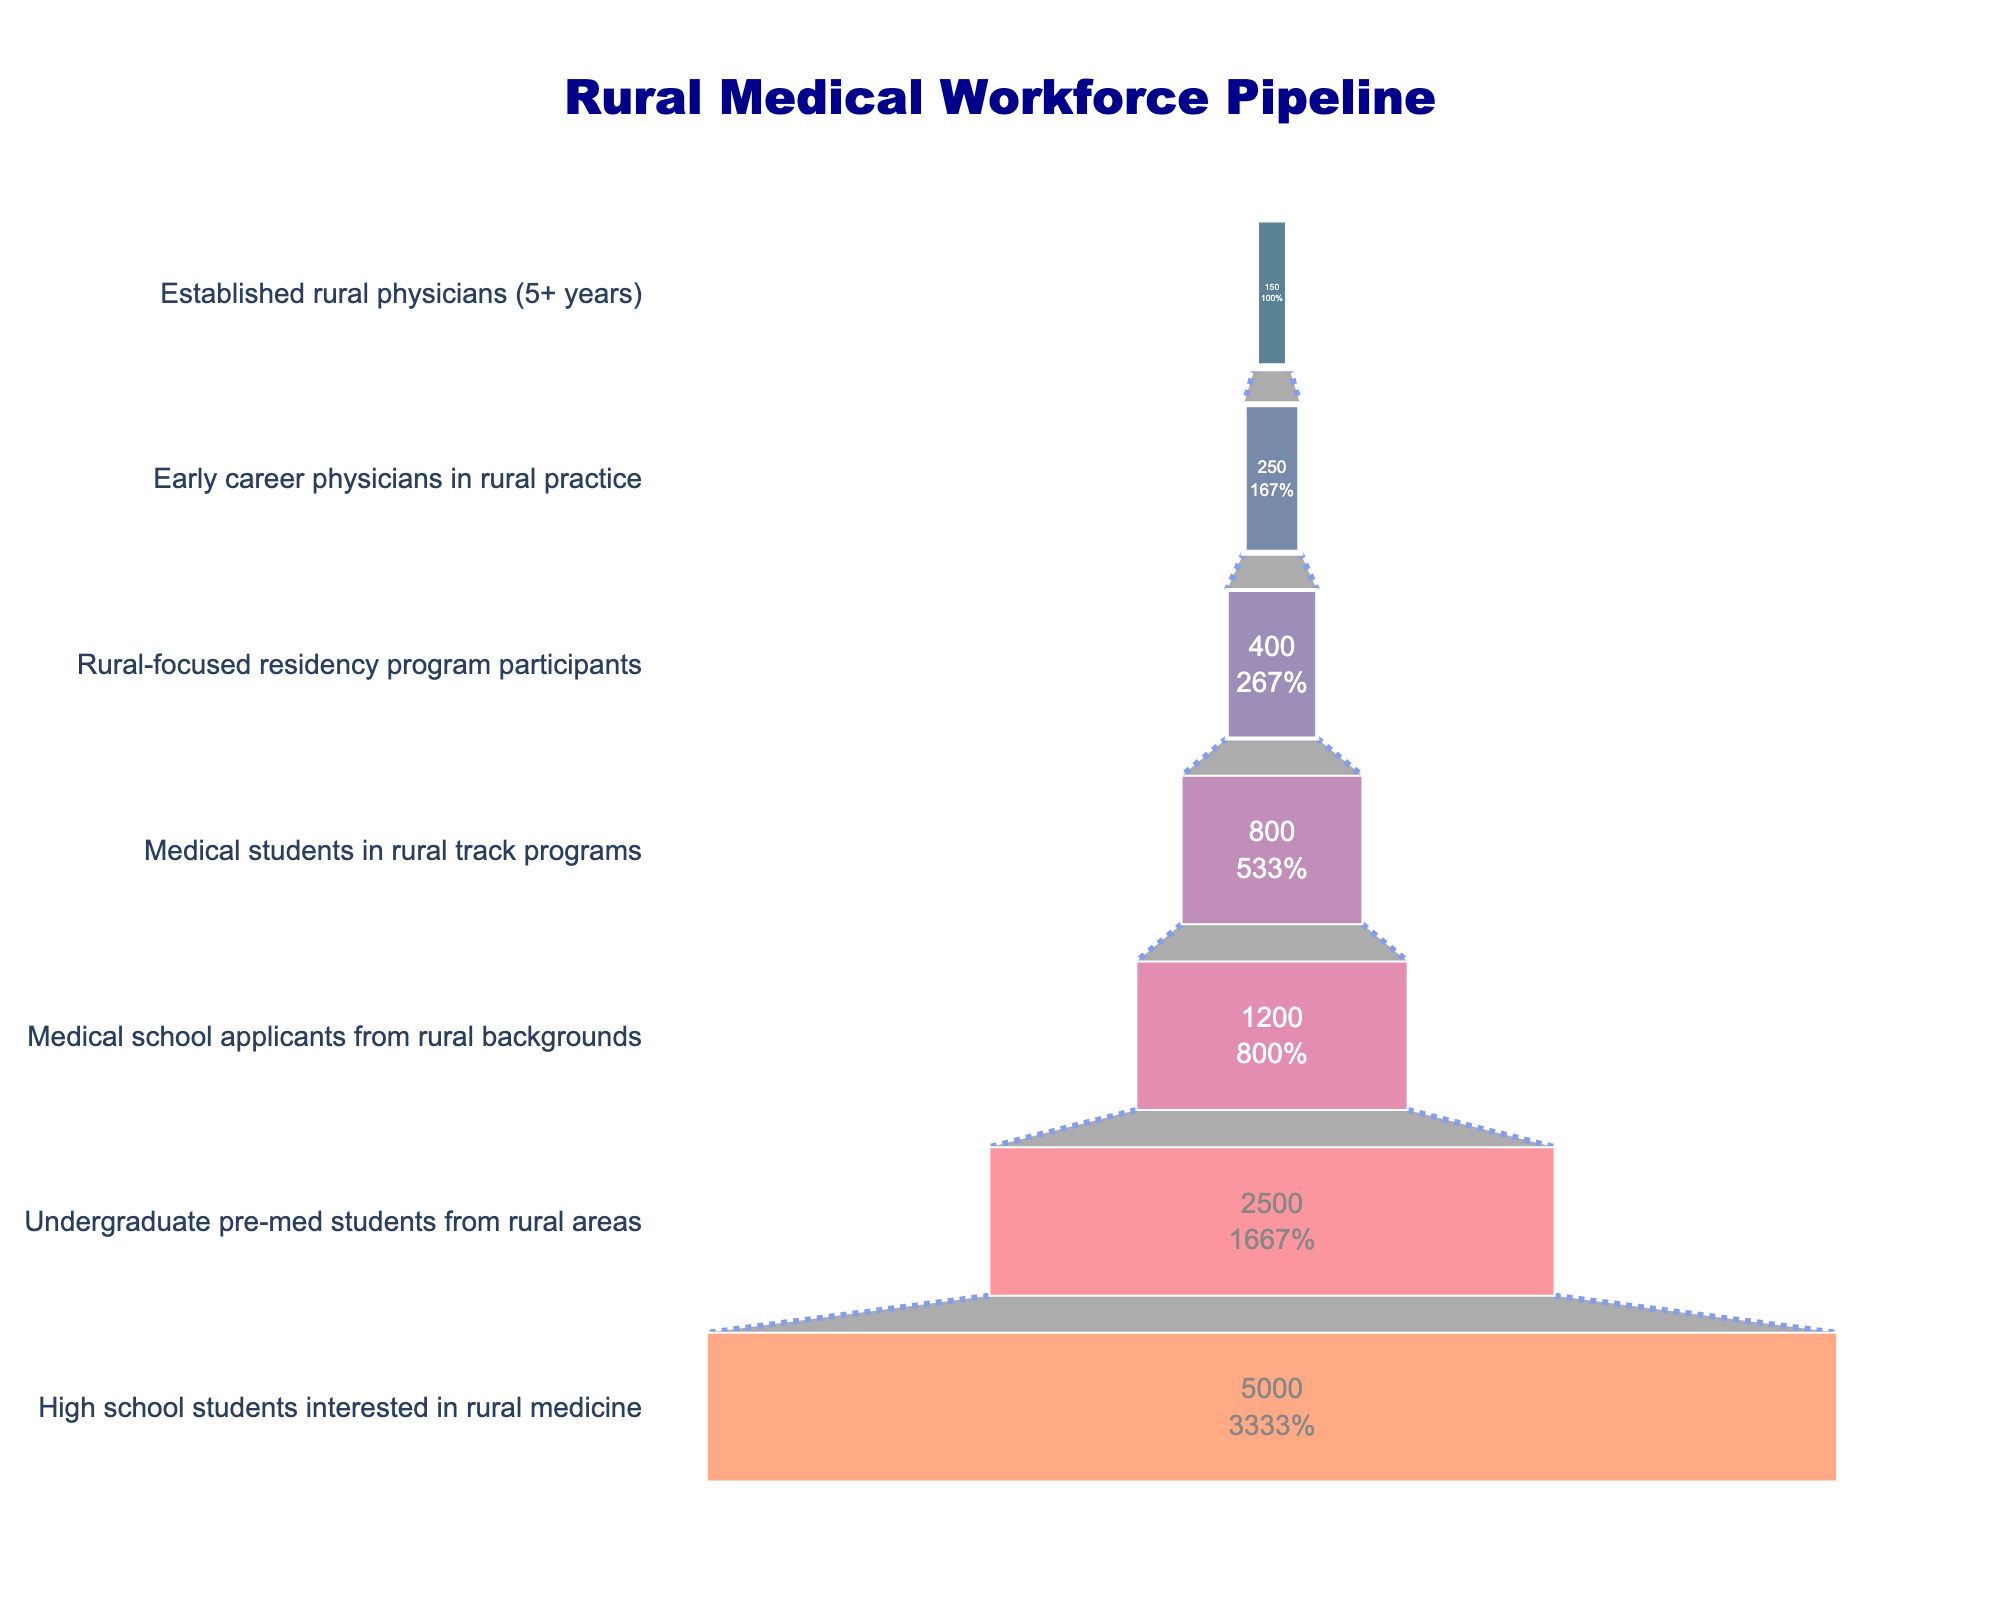Which stage has the highest number of individuals? The stage with the highest number of individuals is the first stage, which is "High school students interested in rural medicine." This stage has 5000 individuals.
Answer: High school students interested in rural medicine What percentage of high school students interested in rural medicine actually become established rural physicians? There are 5000 high school students interested in rural medicine and 150 established rural physicians. The percentage is (150/5000) * 100%.
Answer: 3% How many individuals drop out between the undergraduate pre-med stage and the medical school application stage? There are 2500 undergraduate pre-med students from rural areas and 1200 medical school applicants from rural backgrounds. The difference is 2500 - 1200.
Answer: 1300 What proportion of medical students in rural track programs transition into rural-focused residency programs? There are 800 medical students in rural track programs and 400 rural-focused residency program participants. The proportion is 400/800.
Answer: 0.5 Which stage experiences the highest drop-off in absolute numbers? The highest drop-off in absolute numbers occurs between "High school students interested in rural medicine" and "Undergraduate pre-med students from rural areas." The drop-off is 5000 - 2500.
Answer: 2500 What is the median number of individuals across the stages? The numbers for each stage are: 5000, 2500, 1200, 800, 400, 250, and 150. Arranged in ascending order: 150, 250, 400, 800, 1200, 2500, 5000. The median value is the middle one, which is 800.
Answer: 800 Between which two stages does the smallest drop in individuals occur? The smallest drop in individuals occurs between "Rural-focused residency program participants" and "Early career physicians in rural practice." The drop is 400 - 250.
Answer: Rural-focused residency program participants and Early career physicians in rural practice What is the total number of individuals represented in the entire pipeline? The sum of individuals across all stages is 5000 + 2500 + 1200 + 800 + 400 + 250 + 150.
Answer: 10300 By what factor does the number of established rural physicians differ from the number of medical school applicants? There are 150 established rural physicians and 1200 medical school applicants. The factor is 1200/150.
Answer: 8 What percentage of medical school applicants from rural backgrounds end up in the early career rural practice stage? There are 1200 medical school applicants from rural backgrounds and 250 early career physicians in rural practice. The percentage is (250/1200)*100%.
Answer: 20.83% 